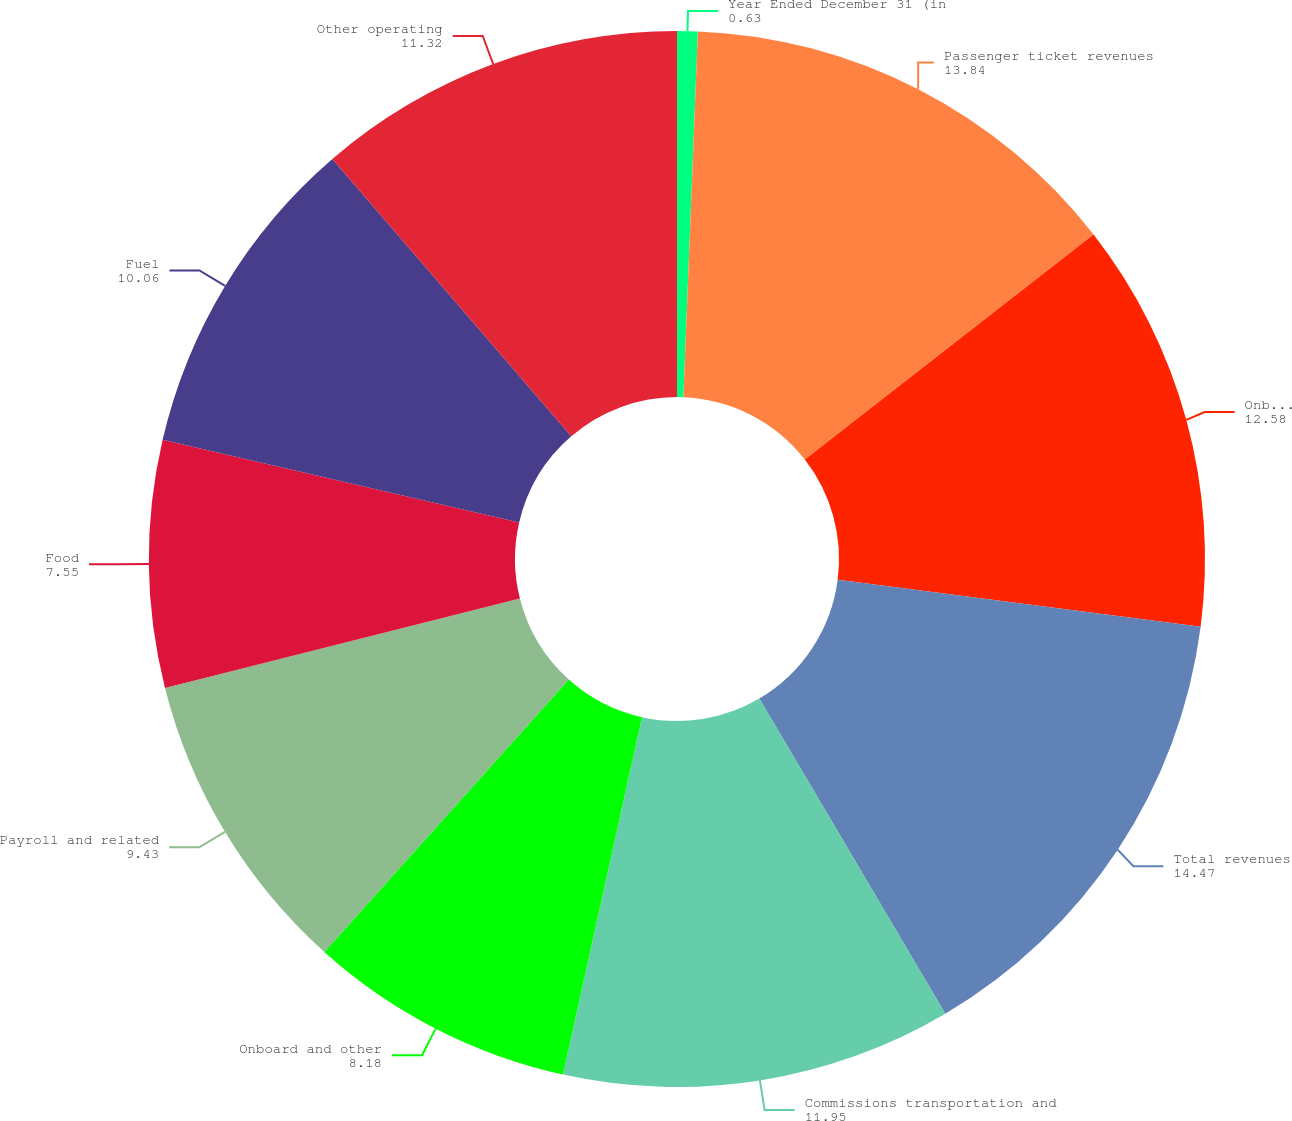Convert chart to OTSL. <chart><loc_0><loc_0><loc_500><loc_500><pie_chart><fcel>Year Ended December 31 (in<fcel>Passenger ticket revenues<fcel>Onboard and other revenues<fcel>Total revenues<fcel>Commissions transportation and<fcel>Onboard and other<fcel>Payroll and related<fcel>Food<fcel>Fuel<fcel>Other operating<nl><fcel>0.63%<fcel>13.84%<fcel>12.58%<fcel>14.47%<fcel>11.95%<fcel>8.18%<fcel>9.43%<fcel>7.55%<fcel>10.06%<fcel>11.32%<nl></chart> 